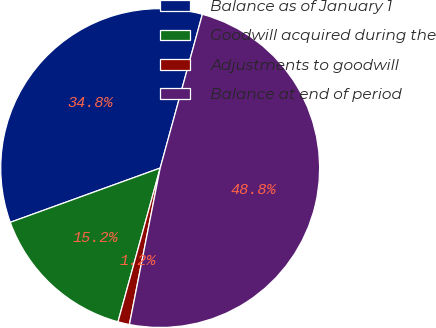Convert chart. <chart><loc_0><loc_0><loc_500><loc_500><pie_chart><fcel>Balance as of January 1<fcel>Goodwill acquired during the<fcel>Adjustments to goodwill<fcel>Balance at end of period<nl><fcel>34.79%<fcel>15.21%<fcel>1.17%<fcel>48.83%<nl></chart> 